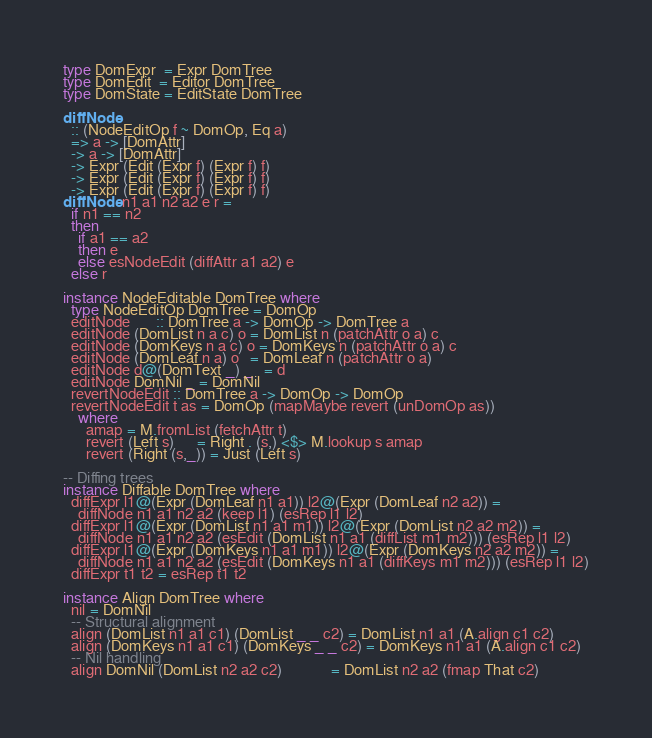Convert code to text. <code><loc_0><loc_0><loc_500><loc_500><_Haskell_>type DomExpr  = Expr DomTree
type DomEdit  = Editor DomTree
type DomState = EditState DomTree

diffNode
  :: (NodeEditOp f ~ DomOp, Eq a)
  => a -> [DomAttr]
  -> a -> [DomAttr]
  -> Expr (Edit (Expr f) (Expr f) f)
  -> Expr (Edit (Expr f) (Expr f) f)
  -> Expr (Edit (Expr f) (Expr f) f)
diffNode n1 a1 n2 a2 e r =
  if n1 == n2
  then
    if a1 == a2
    then e
    else esNodeEdit (diffAttr a1 a2) e
  else r

instance NodeEditable DomTree where
  type NodeEditOp DomTree = DomOp
  editNode       :: DomTree a -> DomOp -> DomTree a
  editNode (DomList n a c) o = DomList n (patchAttr o a) c
  editNode (DomKeys n a c) o = DomKeys n (patchAttr o a) c
  editNode (DomLeaf n a) o   = DomLeaf n (patchAttr o a)
  editNode d@(DomText _) _   = d
  editNode DomNil _ = DomNil
  revertNodeEdit :: DomTree a -> DomOp -> DomOp
  revertNodeEdit t as = DomOp (mapMaybe revert (unDomOp as))
    where
      amap = M.fromList (fetchAttr t)
      revert (Left s)      = Right . (s,) <$> M.lookup s amap
      revert (Right (s,_)) = Just (Left s)

-- Diffing trees
instance Diffable DomTree where
  diffExpr l1@(Expr (DomLeaf n1 a1)) l2@(Expr (DomLeaf n2 a2)) =
    diffNode n1 a1 n2 a2 (keep l1) (esRep l1 l2)
  diffExpr l1@(Expr (DomList n1 a1 m1)) l2@(Expr (DomList n2 a2 m2)) =
    diffNode n1 a1 n2 a2 (esEdit (DomList n1 a1 (diffList m1 m2))) (esRep l1 l2)
  diffExpr l1@(Expr (DomKeys n1 a1 m1)) l2@(Expr (DomKeys n2 a2 m2)) =
    diffNode n1 a1 n2 a2 (esEdit (DomKeys n1 a1 (diffKeys m1 m2))) (esRep l1 l2)
  diffExpr t1 t2 = esRep t1 t2

instance Align DomTree where
  nil = DomNil
  -- Structural alignment
  align (DomList n1 a1 c1) (DomList _ _ c2) = DomList n1 a1 (A.align c1 c2)
  align (DomKeys n1 a1 c1) (DomKeys _ _ c2) = DomKeys n1 a1 (A.align c1 c2)
  -- Nil handling
  align DomNil (DomList n2 a2 c2)             = DomList n2 a2 (fmap That c2)</code> 